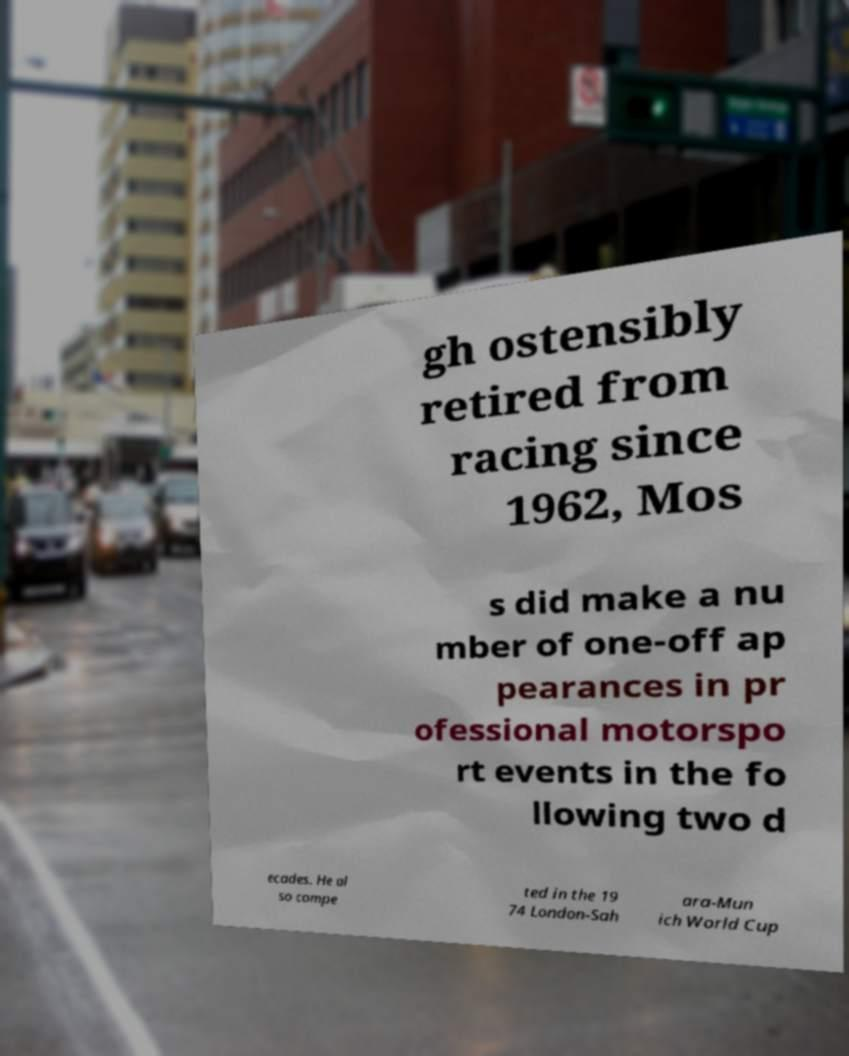Please read and relay the text visible in this image. What does it say? gh ostensibly retired from racing since 1962, Mos s did make a nu mber of one-off ap pearances in pr ofessional motorspo rt events in the fo llowing two d ecades. He al so compe ted in the 19 74 London-Sah ara-Mun ich World Cup 